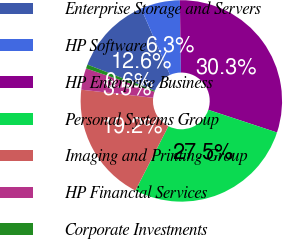<chart> <loc_0><loc_0><loc_500><loc_500><pie_chart><fcel>Enterprise Storage and Servers<fcel>HP Software<fcel>HP Enterprise Business<fcel>Personal Systems Group<fcel>Imaging and Printing Group<fcel>HP Financial Services<fcel>Corporate Investments<nl><fcel>12.6%<fcel>6.3%<fcel>30.31%<fcel>27.47%<fcel>19.24%<fcel>3.46%<fcel>0.63%<nl></chart> 